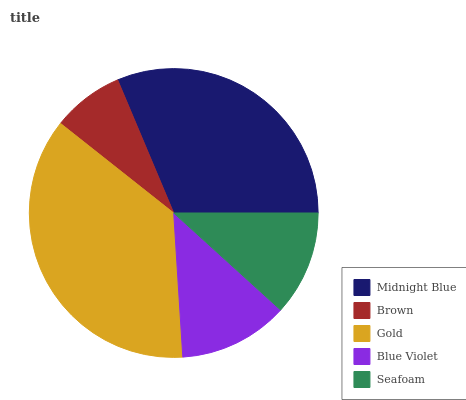Is Brown the minimum?
Answer yes or no. Yes. Is Gold the maximum?
Answer yes or no. Yes. Is Gold the minimum?
Answer yes or no. No. Is Brown the maximum?
Answer yes or no. No. Is Gold greater than Brown?
Answer yes or no. Yes. Is Brown less than Gold?
Answer yes or no. Yes. Is Brown greater than Gold?
Answer yes or no. No. Is Gold less than Brown?
Answer yes or no. No. Is Blue Violet the high median?
Answer yes or no. Yes. Is Blue Violet the low median?
Answer yes or no. Yes. Is Midnight Blue the high median?
Answer yes or no. No. Is Gold the low median?
Answer yes or no. No. 